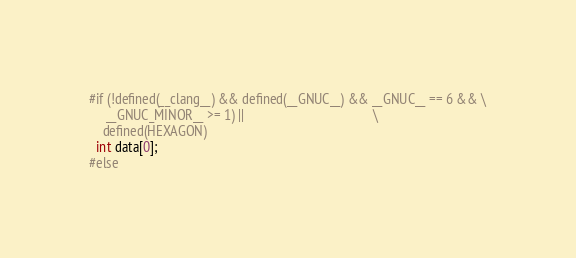<code> <loc_0><loc_0><loc_500><loc_500><_C_>#if (!defined(__clang__) && defined(__GNUC__) && __GNUC__ == 6 && \
     __GNUC_MINOR__ >= 1) ||                                      \
    defined(HEXAGON)
  int data[0];
#else</code> 